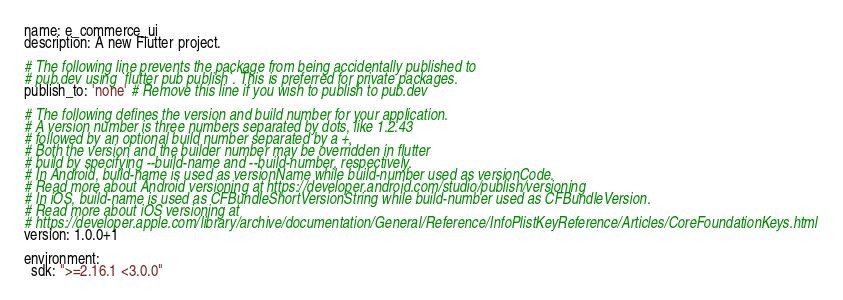Convert code to text. <code><loc_0><loc_0><loc_500><loc_500><_YAML_>name: e_commerce_ui
description: A new Flutter project.

# The following line prevents the package from being accidentally published to
# pub.dev using `flutter pub publish`. This is preferred for private packages.
publish_to: 'none' # Remove this line if you wish to publish to pub.dev

# The following defines the version and build number for your application.
# A version number is three numbers separated by dots, like 1.2.43
# followed by an optional build number separated by a +.
# Both the version and the builder number may be overridden in flutter
# build by specifying --build-name and --build-number, respectively.
# In Android, build-name is used as versionName while build-number used as versionCode.
# Read more about Android versioning at https://developer.android.com/studio/publish/versioning
# In iOS, build-name is used as CFBundleShortVersionString while build-number used as CFBundleVersion.
# Read more about iOS versioning at
# https://developer.apple.com/library/archive/documentation/General/Reference/InfoPlistKeyReference/Articles/CoreFoundationKeys.html
version: 1.0.0+1

environment:
  sdk: ">=2.16.1 <3.0.0"
</code> 